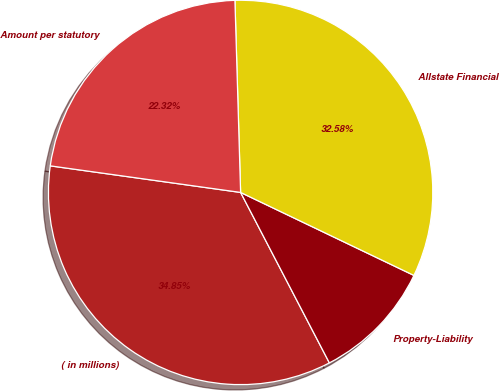Convert chart. <chart><loc_0><loc_0><loc_500><loc_500><pie_chart><fcel>( in millions)<fcel>Property-Liability<fcel>Allstate Financial<fcel>Amount per statutory<nl><fcel>34.85%<fcel>10.25%<fcel>32.58%<fcel>22.32%<nl></chart> 